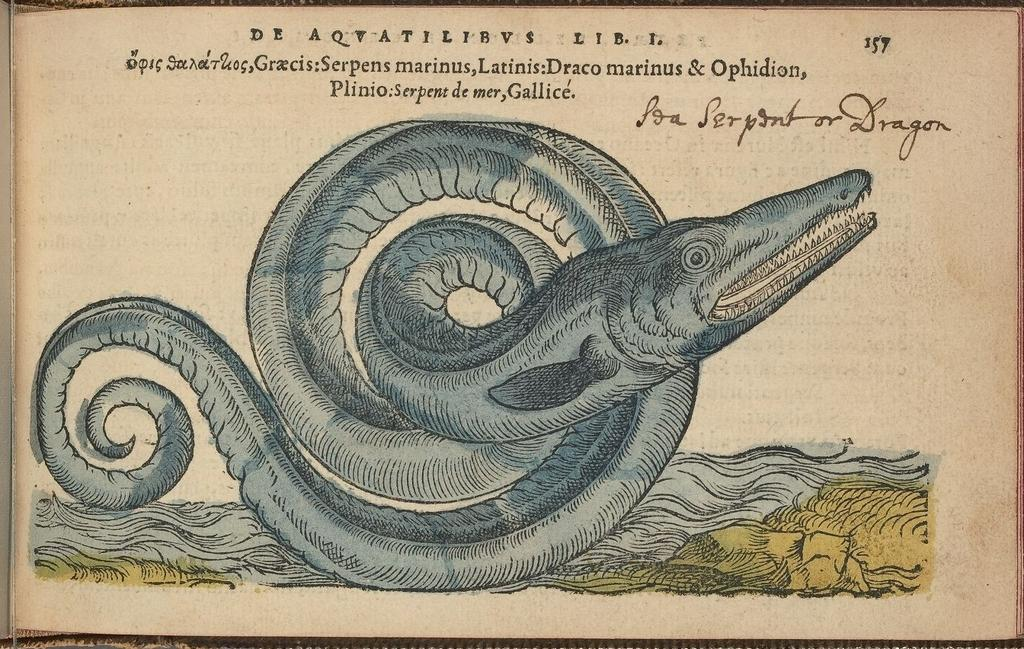What object can be seen on the table in the image? There is a book on the table in the image. What is depicted on the page of the book? The page of the book has a depiction of a snake and crocodile. Is there any text on the page of the book? Yes, there is a quotation at the top of the page. How does the pollution affect the coil in the image? There is no pollution or coil present in the image; it features a book with a page depicting a snake and crocodile. Can you describe the walk of the snake in the image? The image does not show the snake moving or walking; it is a static depiction on the page of the book. 